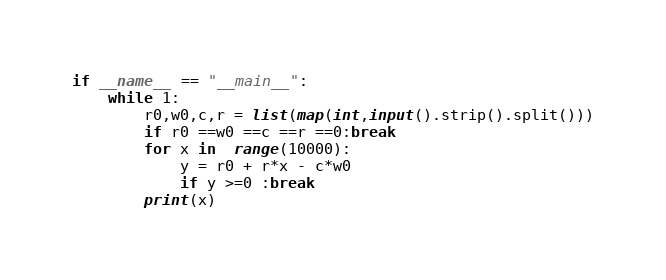Convert code to text. <code><loc_0><loc_0><loc_500><loc_500><_Python_>if __name__ == "__main__":
    while 1:
        r0,w0,c,r = list(map(int,input().strip().split()))
        if r0 ==w0 ==c ==r ==0:break
        for x in  range(10000):
            y = r0 + r*x - c*w0
            if y >=0 :break
        print(x)</code> 